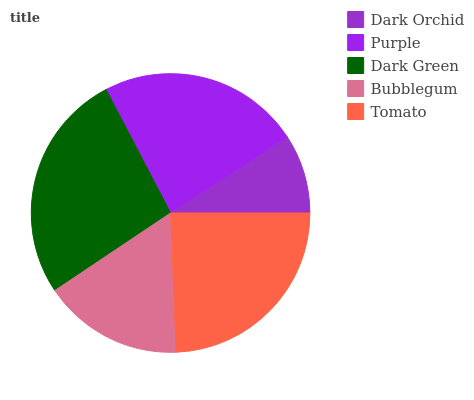Is Dark Orchid the minimum?
Answer yes or no. Yes. Is Dark Green the maximum?
Answer yes or no. Yes. Is Purple the minimum?
Answer yes or no. No. Is Purple the maximum?
Answer yes or no. No. Is Purple greater than Dark Orchid?
Answer yes or no. Yes. Is Dark Orchid less than Purple?
Answer yes or no. Yes. Is Dark Orchid greater than Purple?
Answer yes or no. No. Is Purple less than Dark Orchid?
Answer yes or no. No. Is Purple the high median?
Answer yes or no. Yes. Is Purple the low median?
Answer yes or no. Yes. Is Dark Green the high median?
Answer yes or no. No. Is Bubblegum the low median?
Answer yes or no. No. 